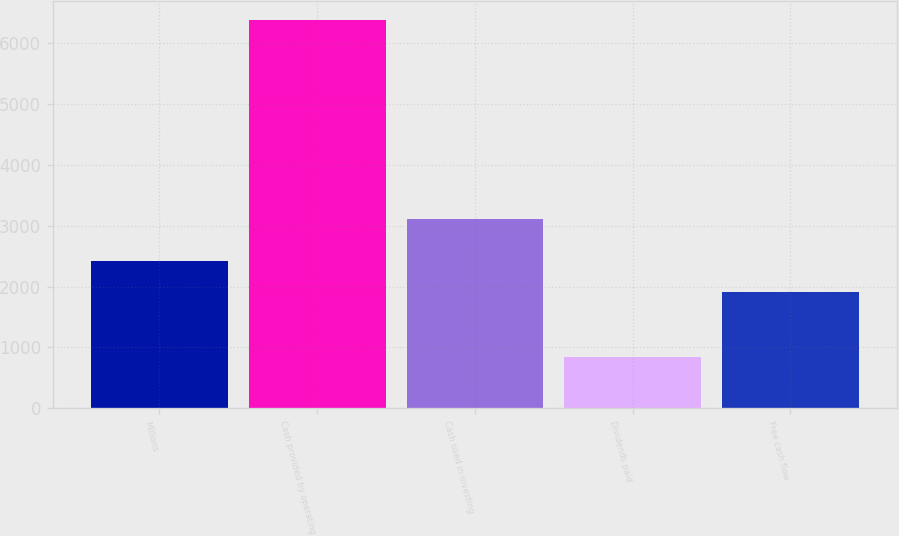Convert chart. <chart><loc_0><loc_0><loc_500><loc_500><bar_chart><fcel>Millions<fcel>Cash provided by operating<fcel>Cash used in investing<fcel>Dividends paid<fcel>Free cash flow<nl><fcel>2420.6<fcel>6376.6<fcel>3119<fcel>837<fcel>1917<nl></chart> 